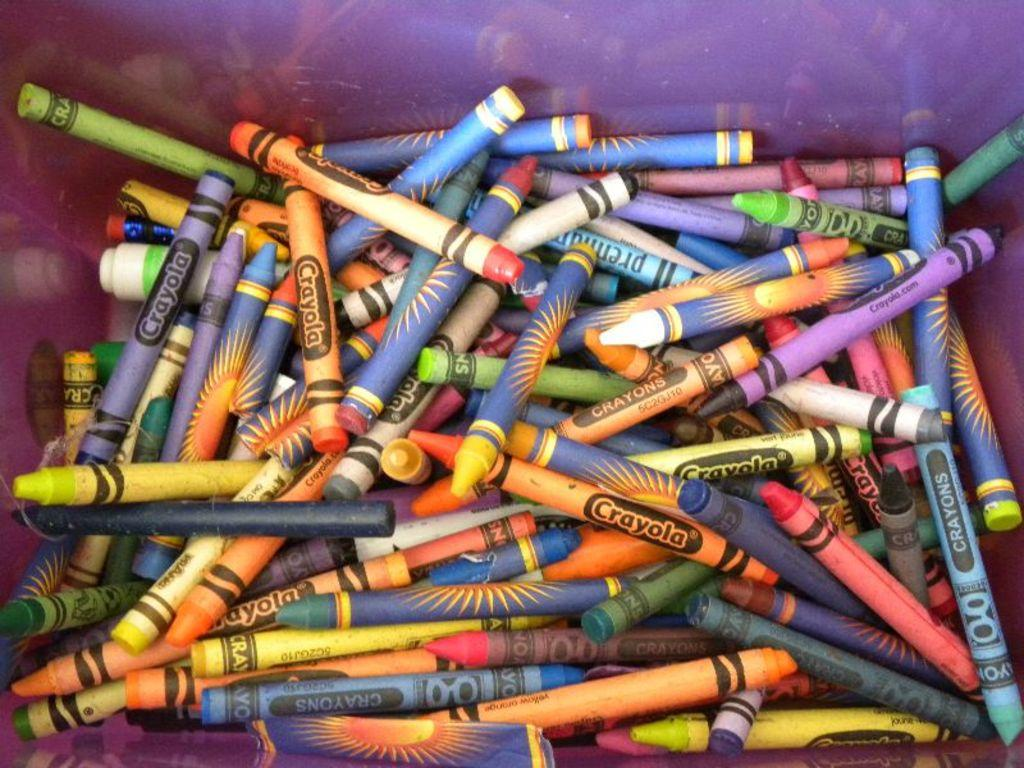<image>
Describe the image concisely. Several crayola crayons are mixed in a bin with non-crayola crayons. 